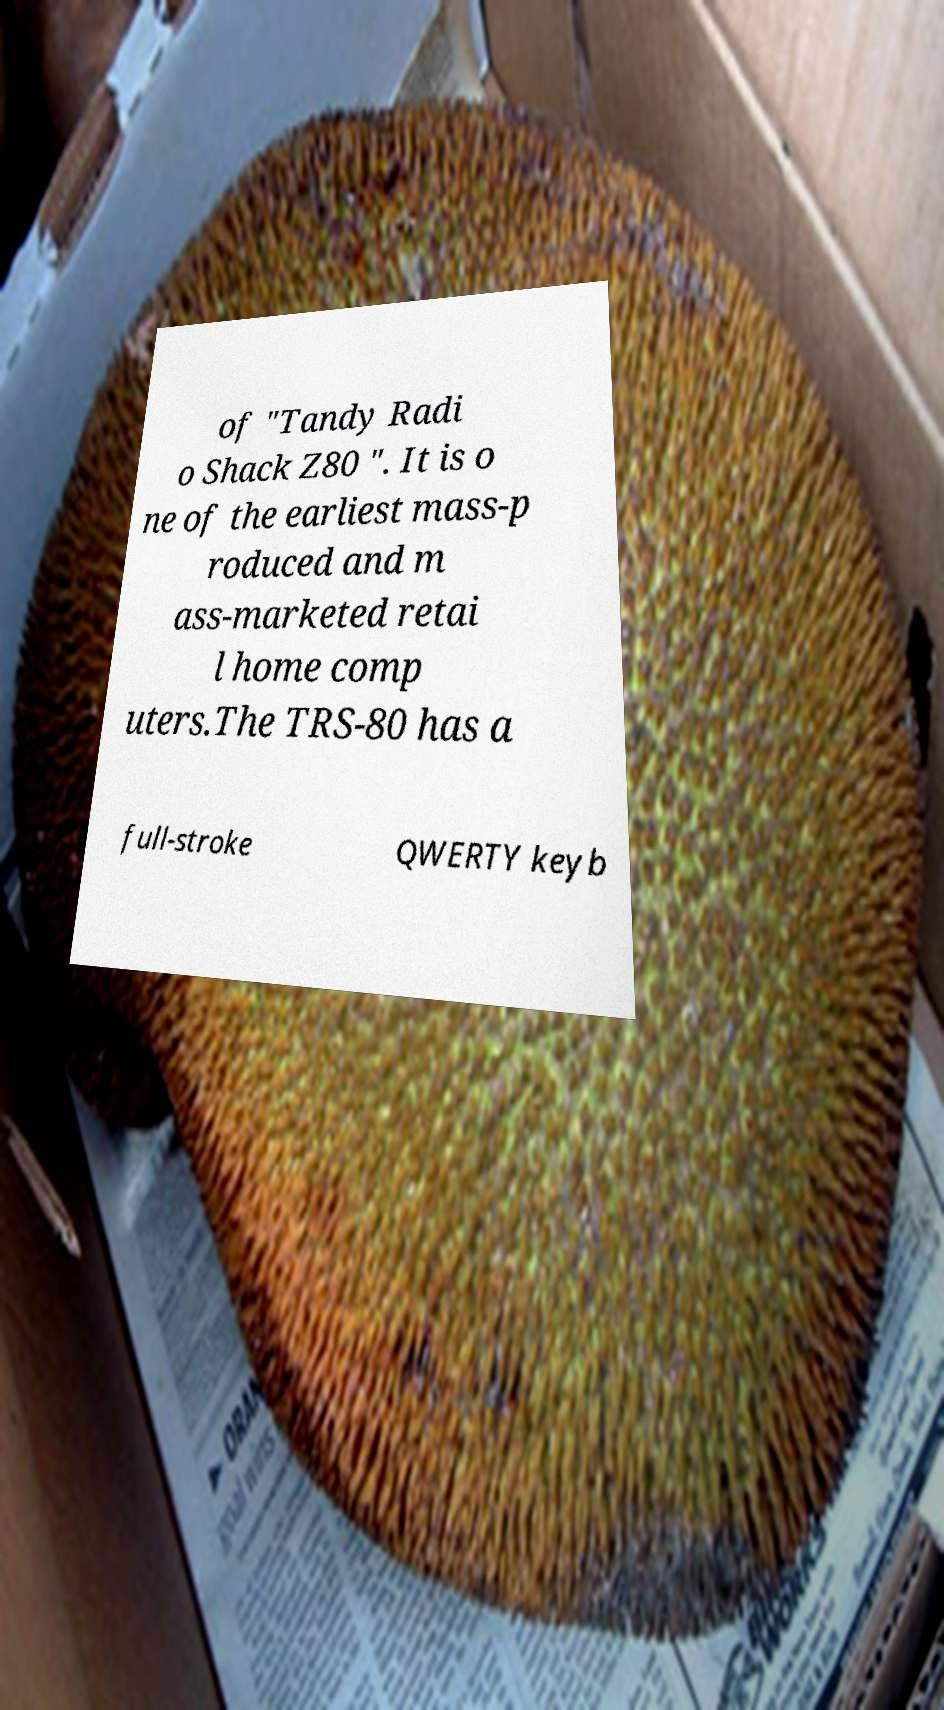For documentation purposes, I need the text within this image transcribed. Could you provide that? of "Tandy Radi o Shack Z80 ". It is o ne of the earliest mass-p roduced and m ass-marketed retai l home comp uters.The TRS-80 has a full-stroke QWERTY keyb 